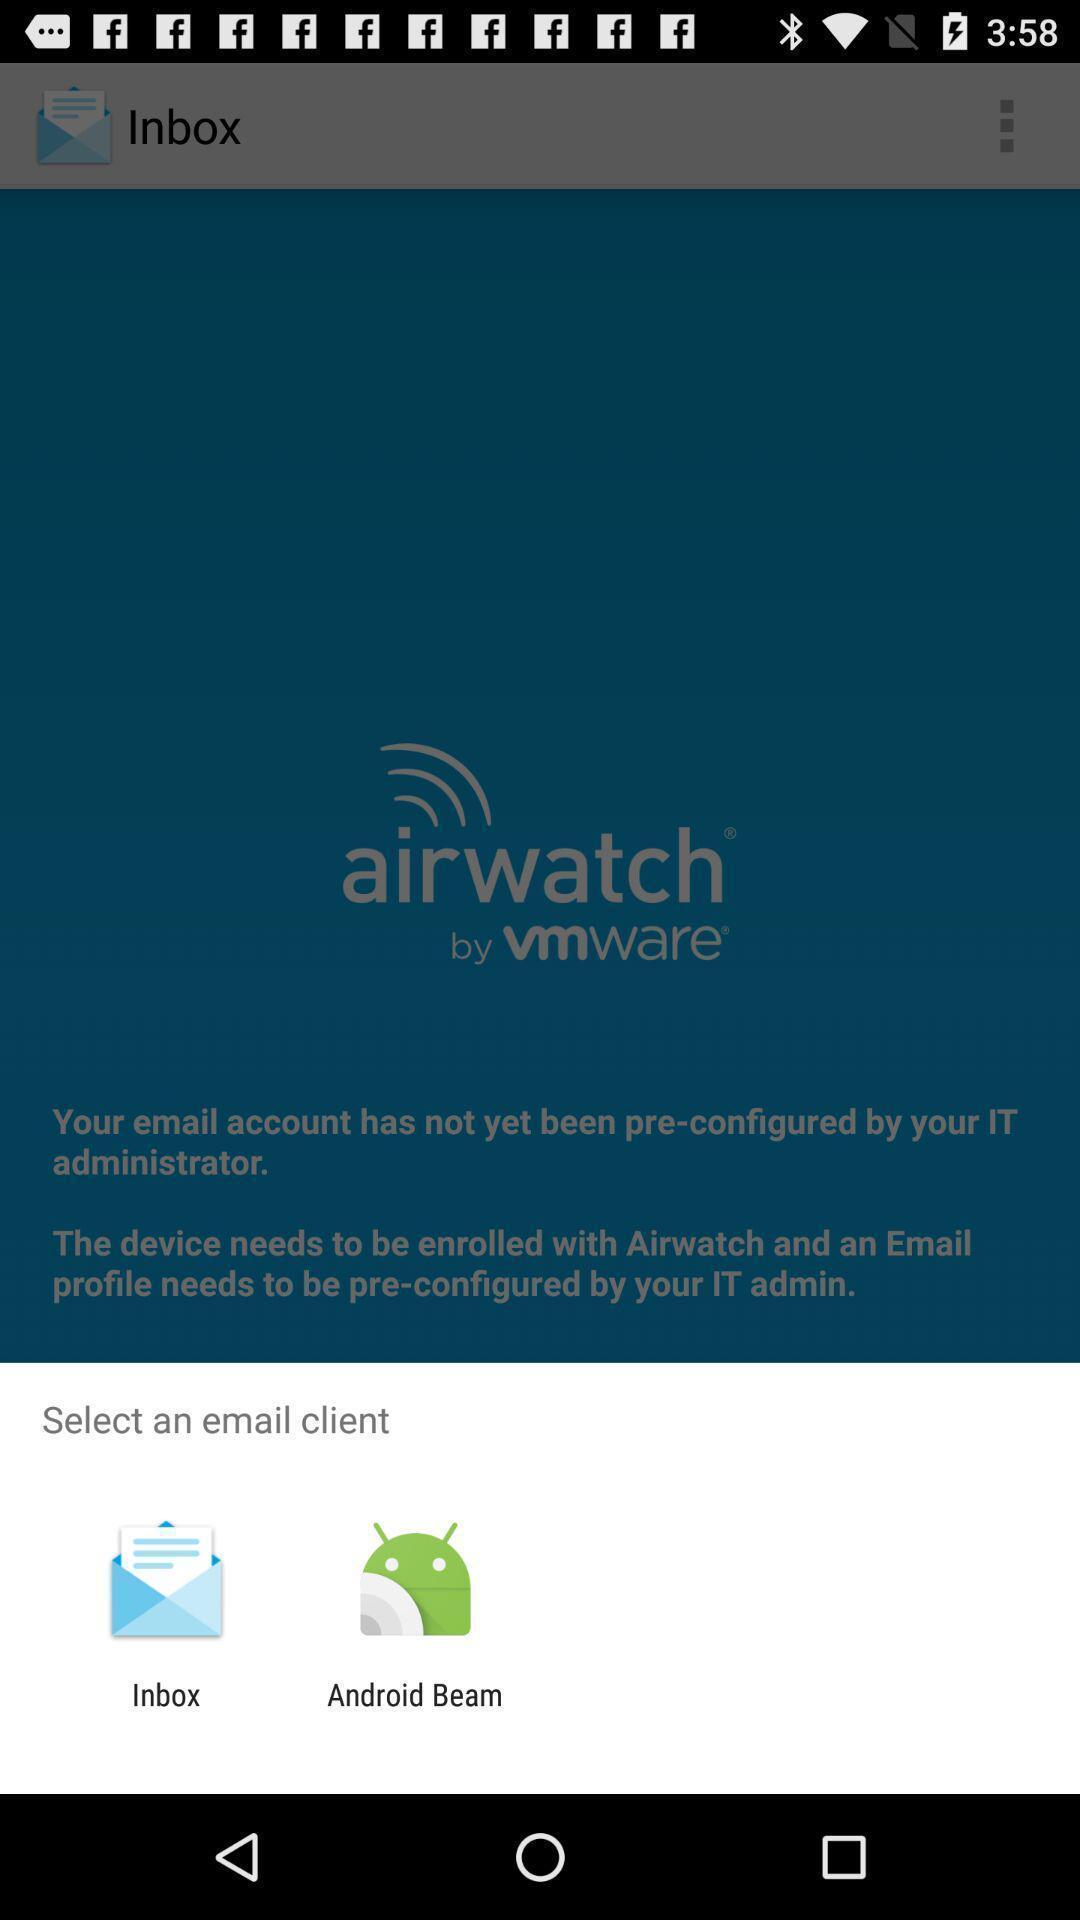What details can you identify in this image? Select an email client of the app. 